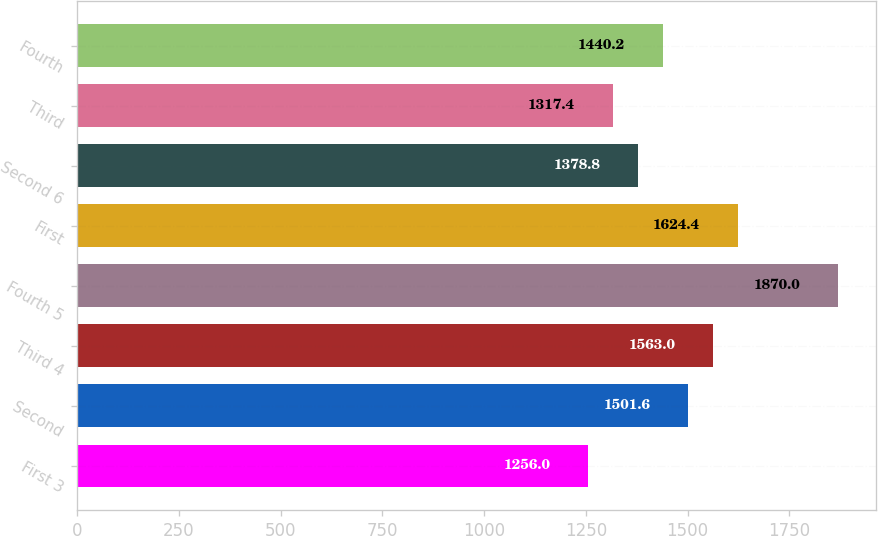<chart> <loc_0><loc_0><loc_500><loc_500><bar_chart><fcel>First 3<fcel>Second<fcel>Third 4<fcel>Fourth 5<fcel>First<fcel>Second 6<fcel>Third<fcel>Fourth<nl><fcel>1256<fcel>1501.6<fcel>1563<fcel>1870<fcel>1624.4<fcel>1378.8<fcel>1317.4<fcel>1440.2<nl></chart> 